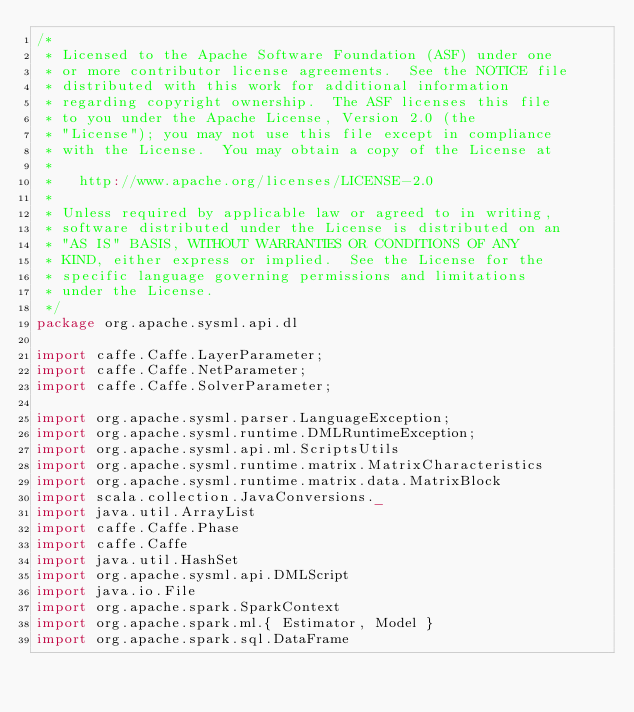<code> <loc_0><loc_0><loc_500><loc_500><_Scala_>/*
 * Licensed to the Apache Software Foundation (ASF) under one
 * or more contributor license agreements.  See the NOTICE file
 * distributed with this work for additional information
 * regarding copyright ownership.  The ASF licenses this file
 * to you under the Apache License, Version 2.0 (the
 * "License"); you may not use this file except in compliance
 * with the License.  You may obtain a copy of the License at
 *
 *   http://www.apache.org/licenses/LICENSE-2.0
 *
 * Unless required by applicable law or agreed to in writing,
 * software distributed under the License is distributed on an
 * "AS IS" BASIS, WITHOUT WARRANTIES OR CONDITIONS OF ANY
 * KIND, either express or implied.  See the License for the
 * specific language governing permissions and limitations
 * under the License.
 */
package org.apache.sysml.api.dl

import caffe.Caffe.LayerParameter;
import caffe.Caffe.NetParameter;
import caffe.Caffe.SolverParameter;

import org.apache.sysml.parser.LanguageException;
import org.apache.sysml.runtime.DMLRuntimeException;
import org.apache.sysml.api.ml.ScriptsUtils
import org.apache.sysml.runtime.matrix.MatrixCharacteristics
import org.apache.sysml.runtime.matrix.data.MatrixBlock
import scala.collection.JavaConversions._
import java.util.ArrayList
import caffe.Caffe.Phase
import caffe.Caffe
import java.util.HashSet
import org.apache.sysml.api.DMLScript
import java.io.File
import org.apache.spark.SparkContext
import org.apache.spark.ml.{ Estimator, Model }
import org.apache.spark.sql.DataFrame</code> 